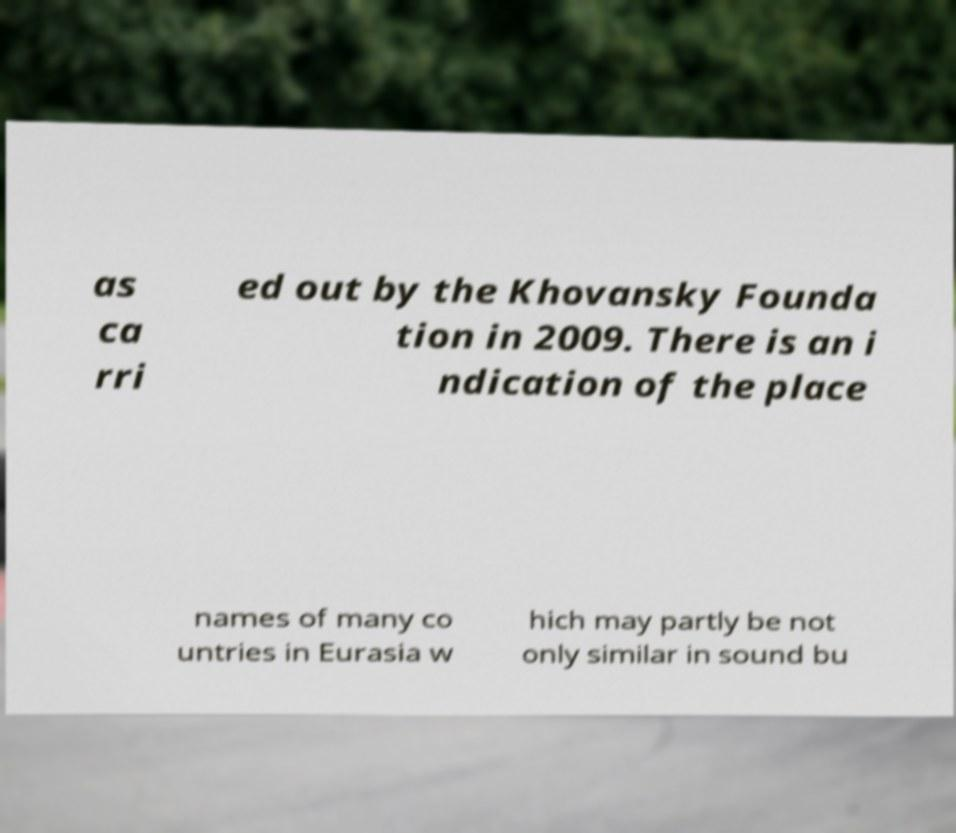For documentation purposes, I need the text within this image transcribed. Could you provide that? as ca rri ed out by the Khovansky Founda tion in 2009. There is an i ndication of the place names of many co untries in Eurasia w hich may partly be not only similar in sound bu 